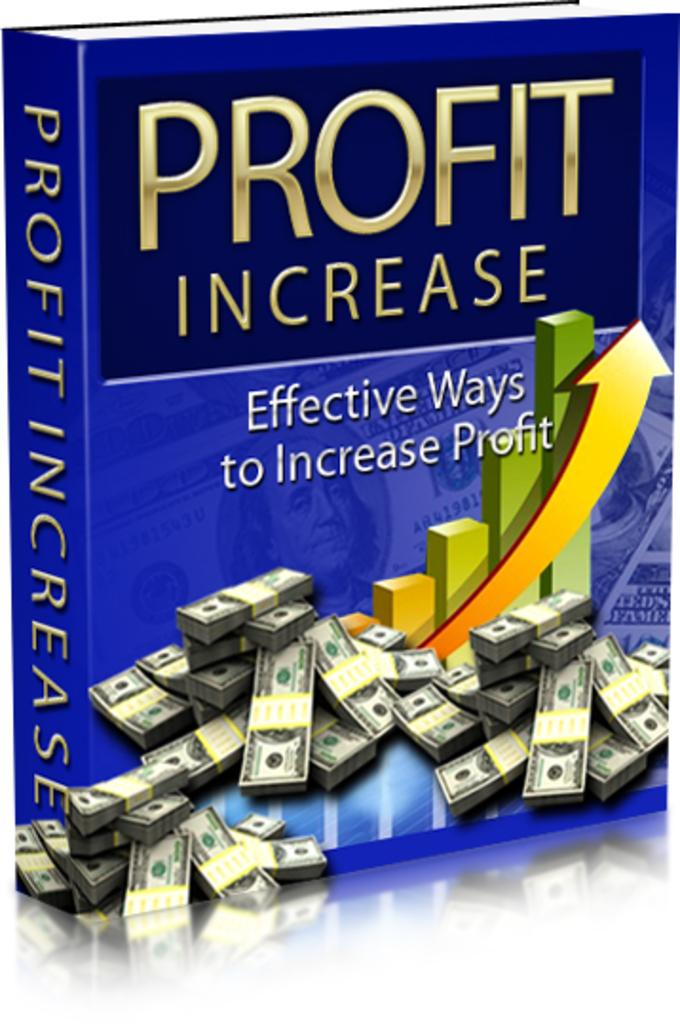<image>
Relay a brief, clear account of the picture shown. a blue book with the words Profit Increase on the ftont 